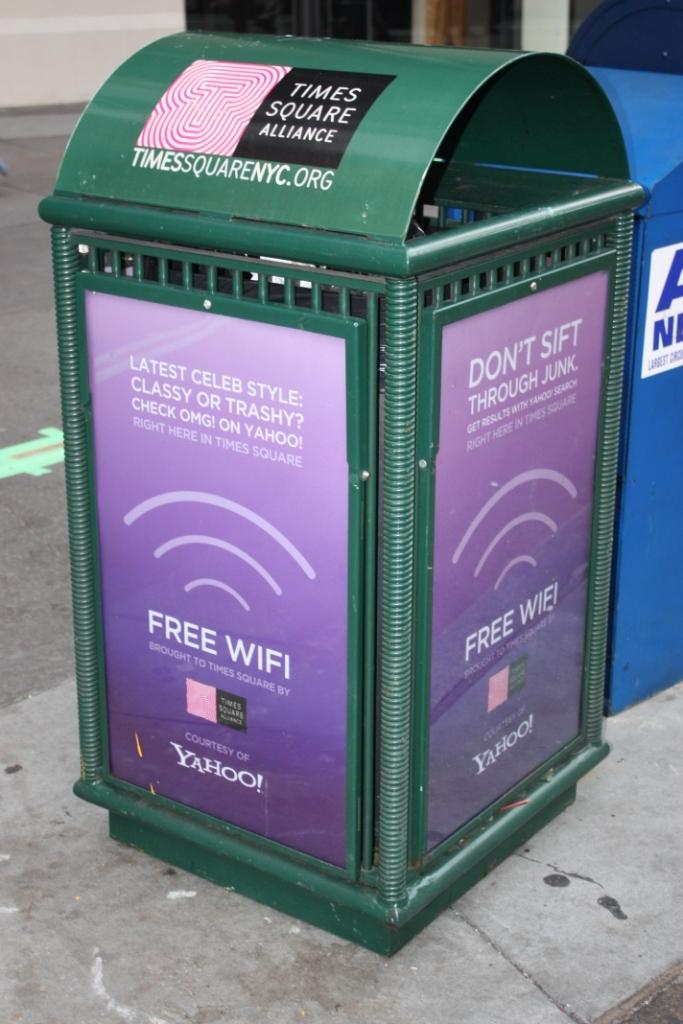What type of signage is visible in the image? There are hoardings in the image. What objects are on the road in the image? There are boxes on the road in the image. When was the image taken? The image is taken during the day. Where was the image taken? The image is taken on a road. What type of suggestion can be seen on the hoardings in the image? There is no suggestion visible on the hoardings in the image; they are simply signage. How many cubs are present on the road in the image? There are no cubs present on the road in the image. 